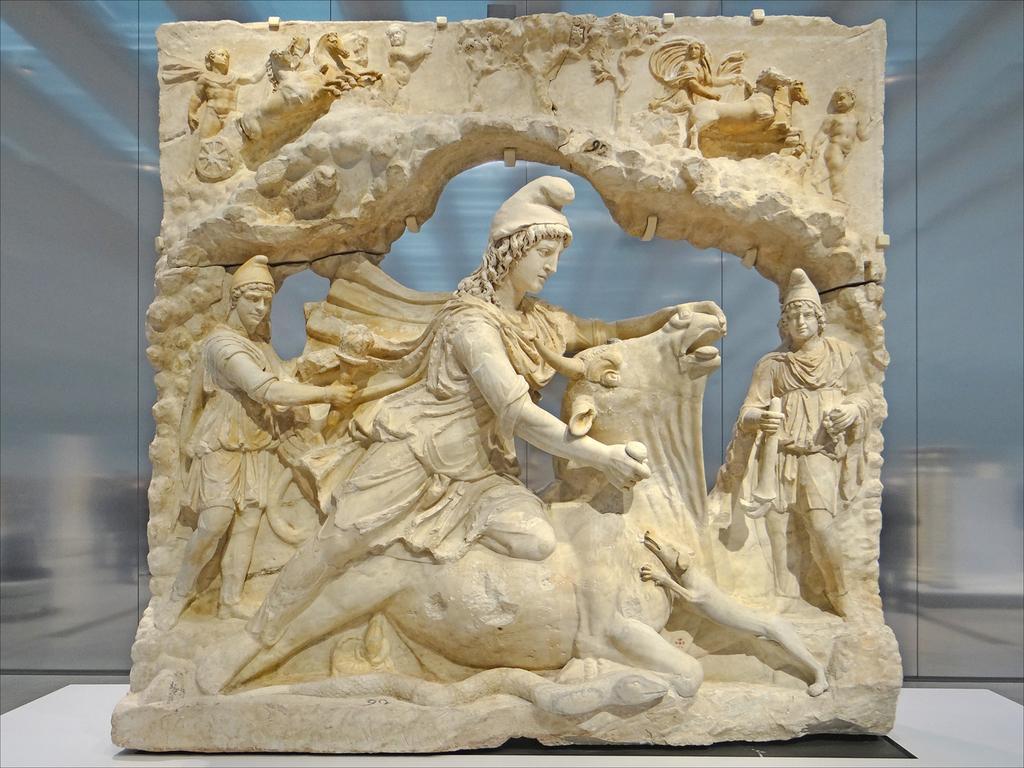Can you describe this image briefly? In this picture we can see a statue on a platform. 